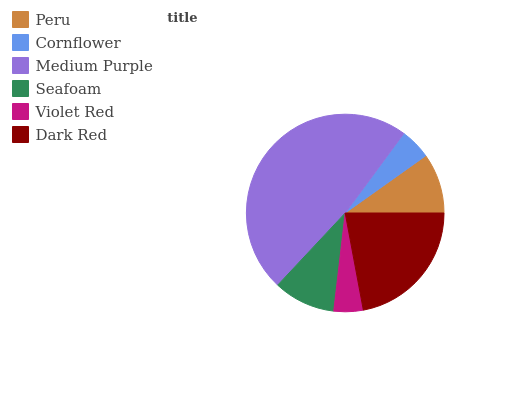Is Violet Red the minimum?
Answer yes or no. Yes. Is Medium Purple the maximum?
Answer yes or no. Yes. Is Cornflower the minimum?
Answer yes or no. No. Is Cornflower the maximum?
Answer yes or no. No. Is Peru greater than Cornflower?
Answer yes or no. Yes. Is Cornflower less than Peru?
Answer yes or no. Yes. Is Cornflower greater than Peru?
Answer yes or no. No. Is Peru less than Cornflower?
Answer yes or no. No. Is Seafoam the high median?
Answer yes or no. Yes. Is Peru the low median?
Answer yes or no. Yes. Is Violet Red the high median?
Answer yes or no. No. Is Medium Purple the low median?
Answer yes or no. No. 